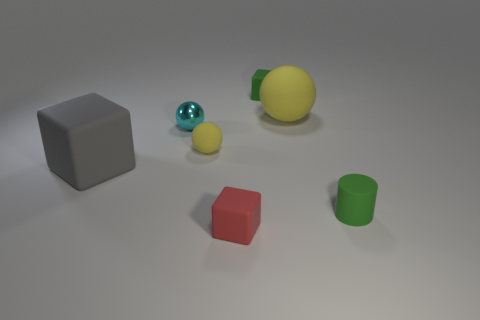There is a rubber thing that is to the left of the small yellow object; does it have the same size as the green thing behind the tiny yellow sphere?
Provide a short and direct response. No. Is the number of tiny green cylinders on the left side of the large gray rubber block the same as the number of green matte cubes that are on the left side of the cyan object?
Provide a succinct answer. Yes. Is there any other thing that is made of the same material as the small cyan object?
Provide a succinct answer. No. There is a cyan shiny thing; is it the same size as the matte block that is in front of the gray block?
Your answer should be compact. Yes. The cyan object behind the block that is on the left side of the tiny red block is made of what material?
Make the answer very short. Metal. Is the number of large matte objects behind the tiny yellow thing the same as the number of large yellow cylinders?
Provide a short and direct response. No. There is a matte thing that is on the right side of the tiny red object and left of the big yellow matte sphere; what is its size?
Keep it short and to the point. Small. There is a tiny matte object that is right of the rubber ball that is right of the small yellow ball; what is its color?
Ensure brevity in your answer.  Green. What number of blue things are big rubber blocks or tiny rubber blocks?
Your answer should be compact. 0. There is a cube that is on the right side of the large gray thing and to the left of the small green matte cube; what color is it?
Offer a terse response. Red. 